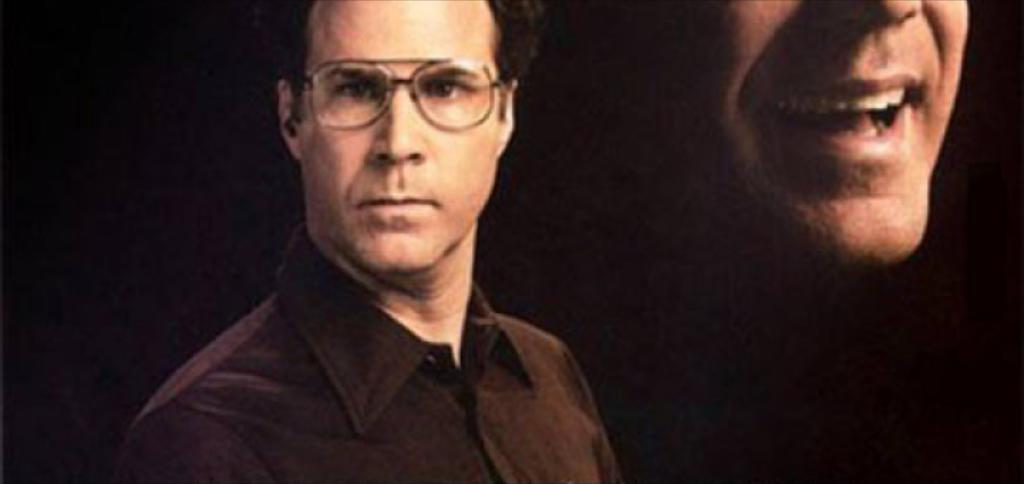What is the main subject of the image? There is a person in the image. Can you describe the person's appearance? The person is wearing spectacles. What is the person doing in the image? The person is in a smiling pose. What type of hope can be seen in the image? There is no specific type of hope present in the image; it features a person wearing spectacles and smiling. What role does the judge play in the image? There is no judge present in the image. 